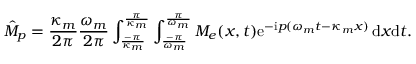<formula> <loc_0><loc_0><loc_500><loc_500>\hat { M } _ { p } = \frac { \kappa _ { m } } { 2 \pi } \frac { \omega _ { m } } { 2 \pi } \int _ { \frac { - \pi } { \kappa _ { m } } } ^ { \frac { \pi } { \kappa _ { m } } } \int _ { \frac { - \pi } { \omega _ { m } } } ^ { \frac { \pi } { \omega _ { m } } } M _ { e } ( x , t ) e ^ { - i p ( \omega _ { m } t - \kappa _ { m } x ) } \, d x d t .</formula> 